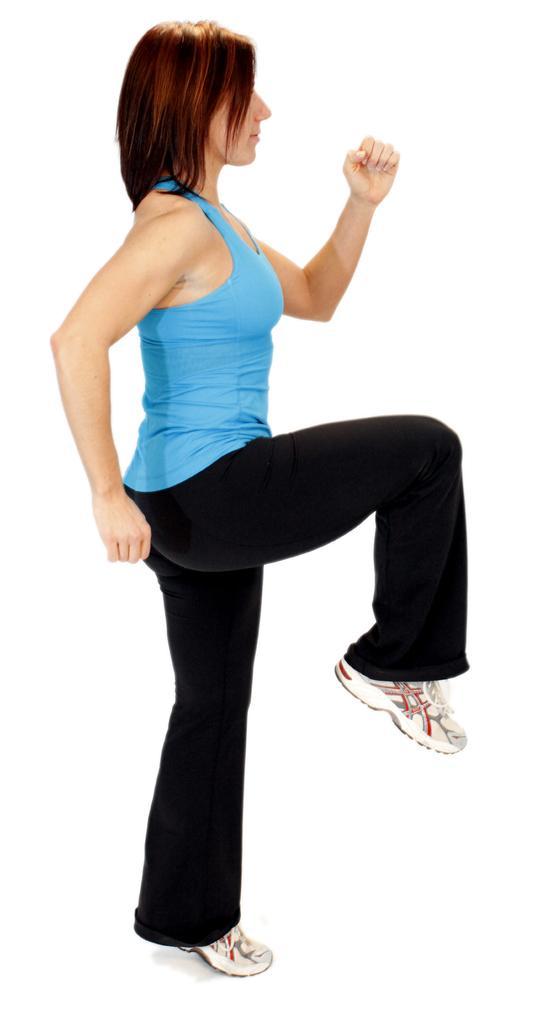Can you describe this image briefly? In this image I can see the person wearing the blue and black color dress and also shoes. And there is a white background. 